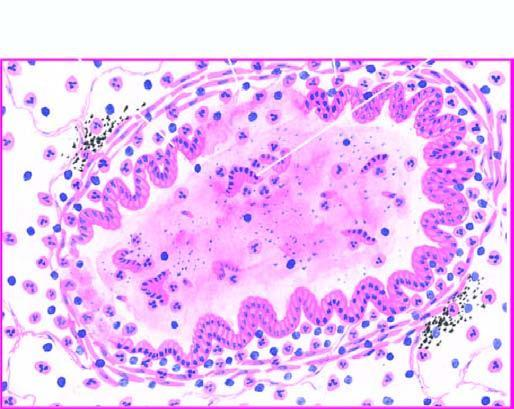what is thickened and infiltrated by acute and chronic inflammatory cells?
Answer the question using a single word or phrase. Bronchial wall 